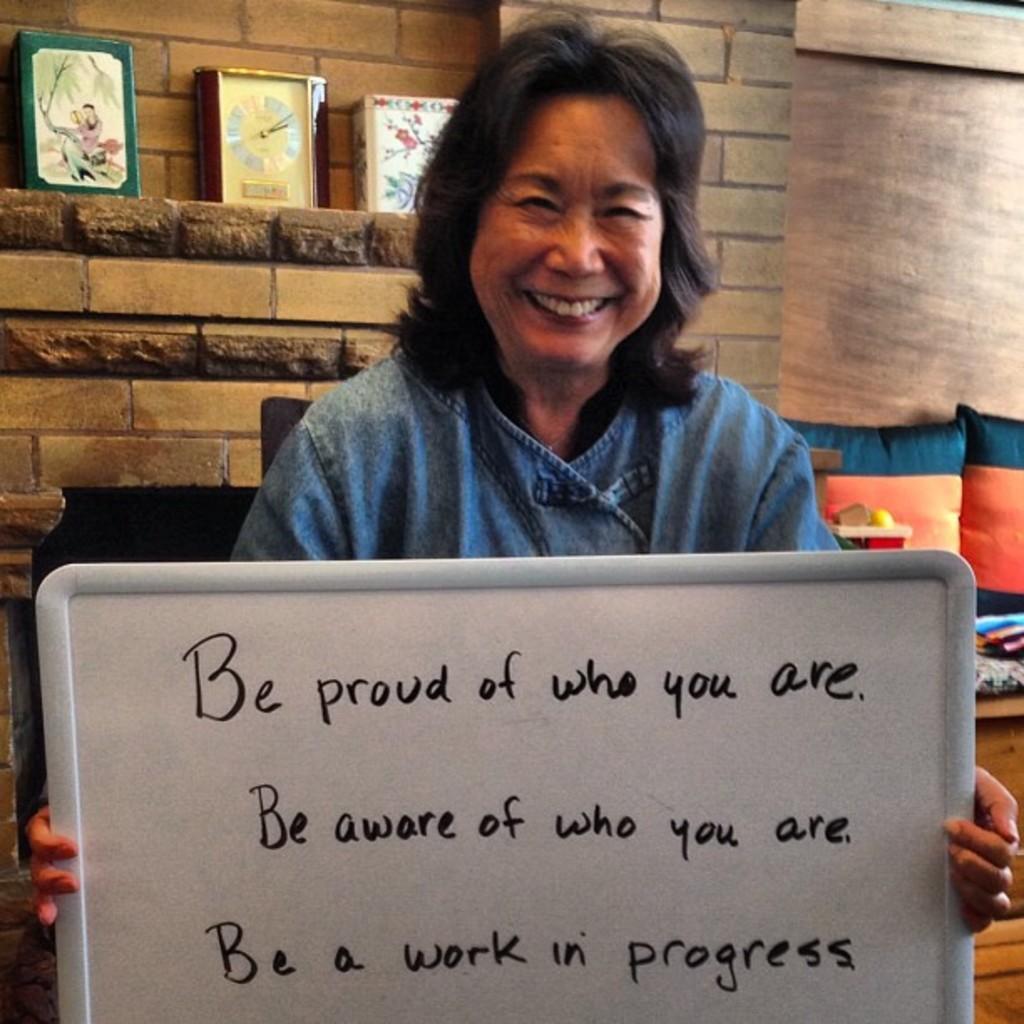In one or two sentences, can you explain what this image depicts? In the image we can see a woman wearing clothes and she is smiling. She is holding a whiteboard, on the board there is a text. Behind her we can see clock, frames and the wall. We can even see there are pillows. 